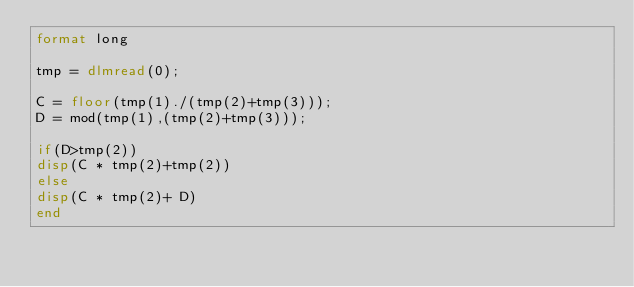<code> <loc_0><loc_0><loc_500><loc_500><_Octave_>format long

tmp = dlmread(0);

C = floor(tmp(1)./(tmp(2)+tmp(3)));
D = mod(tmp(1),(tmp(2)+tmp(3)));

if(D>tmp(2))
disp(C * tmp(2)+tmp(2))
else
disp(C * tmp(2)+ D)
end</code> 